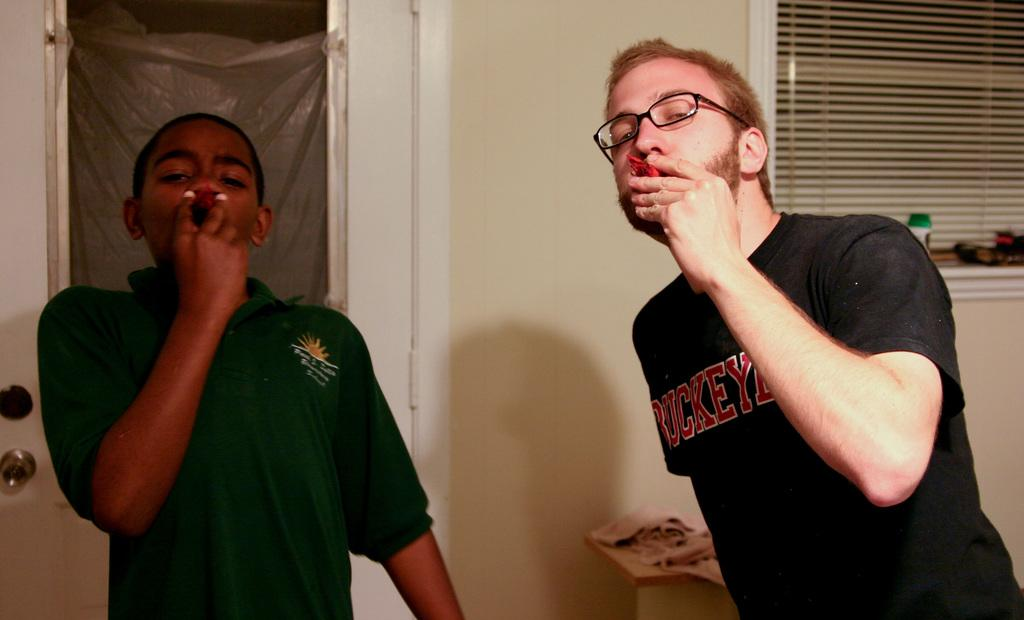How many people are in the image? There are two people in the image. What are the people doing in the image? The people are standing in the image. What are the people holding in the image? The people are holding something in the image. What colors are the dresses of the people in the image? The people are wearing black and green color dresses in the image. What can be seen in the background of the image? There is a window, a cream-colored wall, and a door in the background of the image. Can you see an owl smiling in the image? There is no owl present in the image, and therefore no such activity can be observed. 